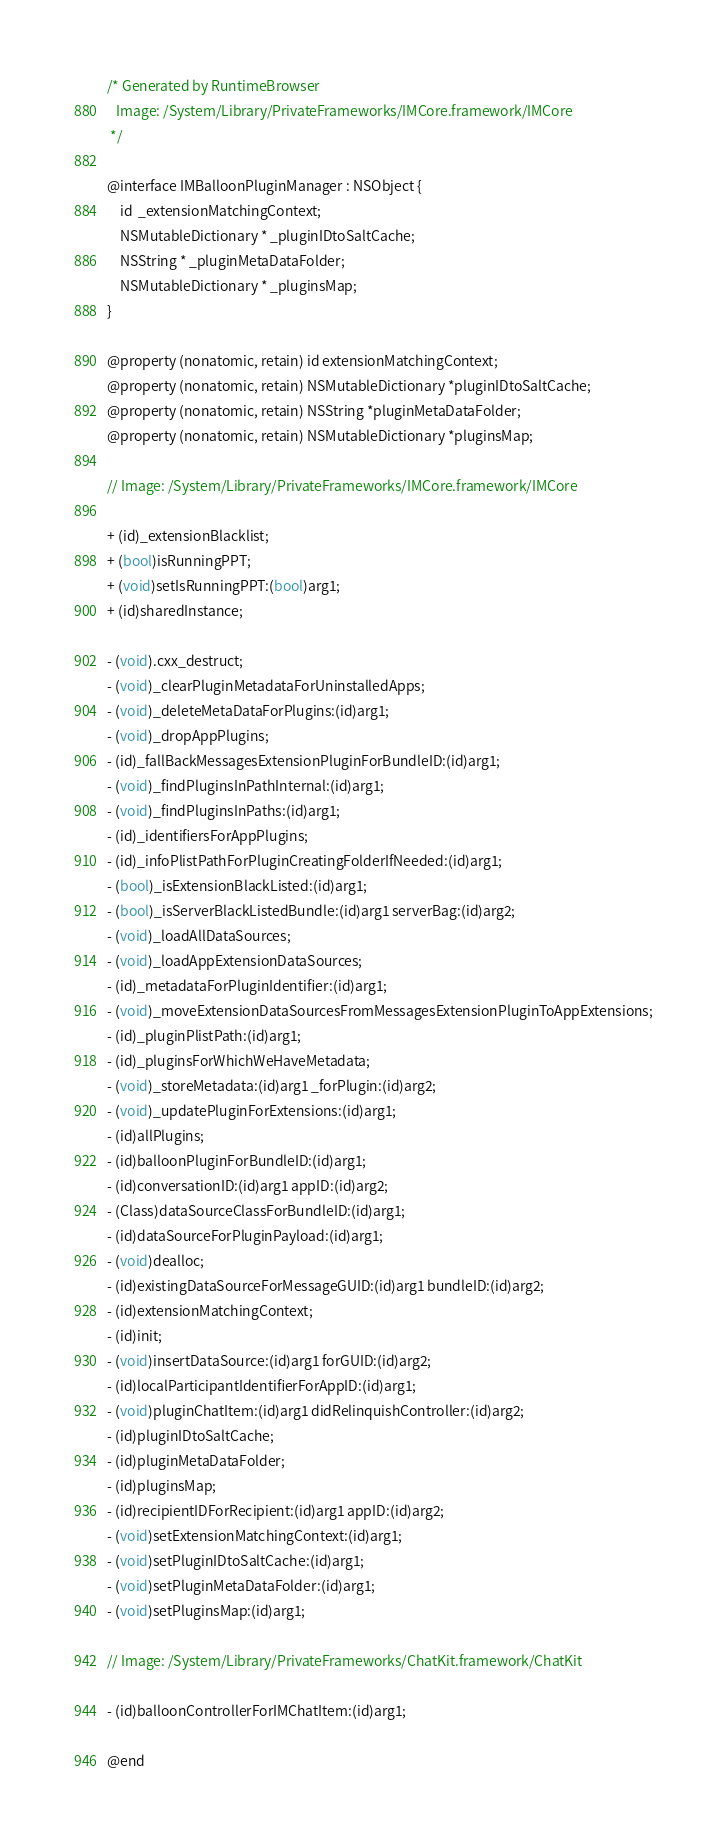<code> <loc_0><loc_0><loc_500><loc_500><_C_>/* Generated by RuntimeBrowser
   Image: /System/Library/PrivateFrameworks/IMCore.framework/IMCore
 */

@interface IMBalloonPluginManager : NSObject {
    id  _extensionMatchingContext;
    NSMutableDictionary * _pluginIDtoSaltCache;
    NSString * _pluginMetaDataFolder;
    NSMutableDictionary * _pluginsMap;
}

@property (nonatomic, retain) id extensionMatchingContext;
@property (nonatomic, retain) NSMutableDictionary *pluginIDtoSaltCache;
@property (nonatomic, retain) NSString *pluginMetaDataFolder;
@property (nonatomic, retain) NSMutableDictionary *pluginsMap;

// Image: /System/Library/PrivateFrameworks/IMCore.framework/IMCore

+ (id)_extensionBlacklist;
+ (bool)isRunningPPT;
+ (void)setIsRunningPPT:(bool)arg1;
+ (id)sharedInstance;

- (void).cxx_destruct;
- (void)_clearPluginMetadataForUninstalledApps;
- (void)_deleteMetaDataForPlugins:(id)arg1;
- (void)_dropAppPlugins;
- (id)_fallBackMessagesExtensionPluginForBundleID:(id)arg1;
- (void)_findPluginsInPathInternal:(id)arg1;
- (void)_findPluginsInPaths:(id)arg1;
- (id)_identifiersForAppPlugins;
- (id)_infoPlistPathForPluginCreatingFolderIfNeeded:(id)arg1;
- (bool)_isExtensionBlackListed:(id)arg1;
- (bool)_isServerBlackListedBundle:(id)arg1 serverBag:(id)arg2;
- (void)_loadAllDataSources;
- (void)_loadAppExtensionDataSources;
- (id)_metadataForPluginIdentifier:(id)arg1;
- (void)_moveExtensionDataSourcesFromMessagesExtensionPluginToAppExtensions;
- (id)_pluginPlistPath:(id)arg1;
- (id)_pluginsForWhichWeHaveMetadata;
- (void)_storeMetadata:(id)arg1 _forPlugin:(id)arg2;
- (void)_updatePluginForExtensions:(id)arg1;
- (id)allPlugins;
- (id)balloonPluginForBundleID:(id)arg1;
- (id)conversationID:(id)arg1 appID:(id)arg2;
- (Class)dataSourceClassForBundleID:(id)arg1;
- (id)dataSourceForPluginPayload:(id)arg1;
- (void)dealloc;
- (id)existingDataSourceForMessageGUID:(id)arg1 bundleID:(id)arg2;
- (id)extensionMatchingContext;
- (id)init;
- (void)insertDataSource:(id)arg1 forGUID:(id)arg2;
- (id)localParticipantIdentifierForAppID:(id)arg1;
- (void)pluginChatItem:(id)arg1 didRelinquishController:(id)arg2;
- (id)pluginIDtoSaltCache;
- (id)pluginMetaDataFolder;
- (id)pluginsMap;
- (id)recipientIDForRecipient:(id)arg1 appID:(id)arg2;
- (void)setExtensionMatchingContext:(id)arg1;
- (void)setPluginIDtoSaltCache:(id)arg1;
- (void)setPluginMetaDataFolder:(id)arg1;
- (void)setPluginsMap:(id)arg1;

// Image: /System/Library/PrivateFrameworks/ChatKit.framework/ChatKit

- (id)balloonControllerForIMChatItem:(id)arg1;

@end
</code> 